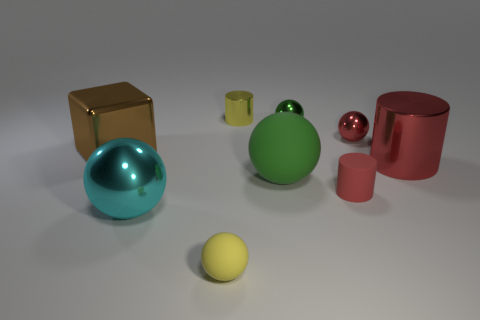Subtract all red cylinders. How many were subtracted if there are1red cylinders left? 1 Subtract all red spheres. How many spheres are left? 4 Subtract all big green balls. How many balls are left? 4 Subtract all brown balls. Subtract all blue cubes. How many balls are left? 5 Add 1 gray balls. How many objects exist? 10 Subtract all spheres. How many objects are left? 4 Subtract 1 yellow cylinders. How many objects are left? 8 Subtract all small cyan shiny cylinders. Subtract all small cylinders. How many objects are left? 7 Add 5 tiny spheres. How many tiny spheres are left? 8 Add 3 metal cylinders. How many metal cylinders exist? 5 